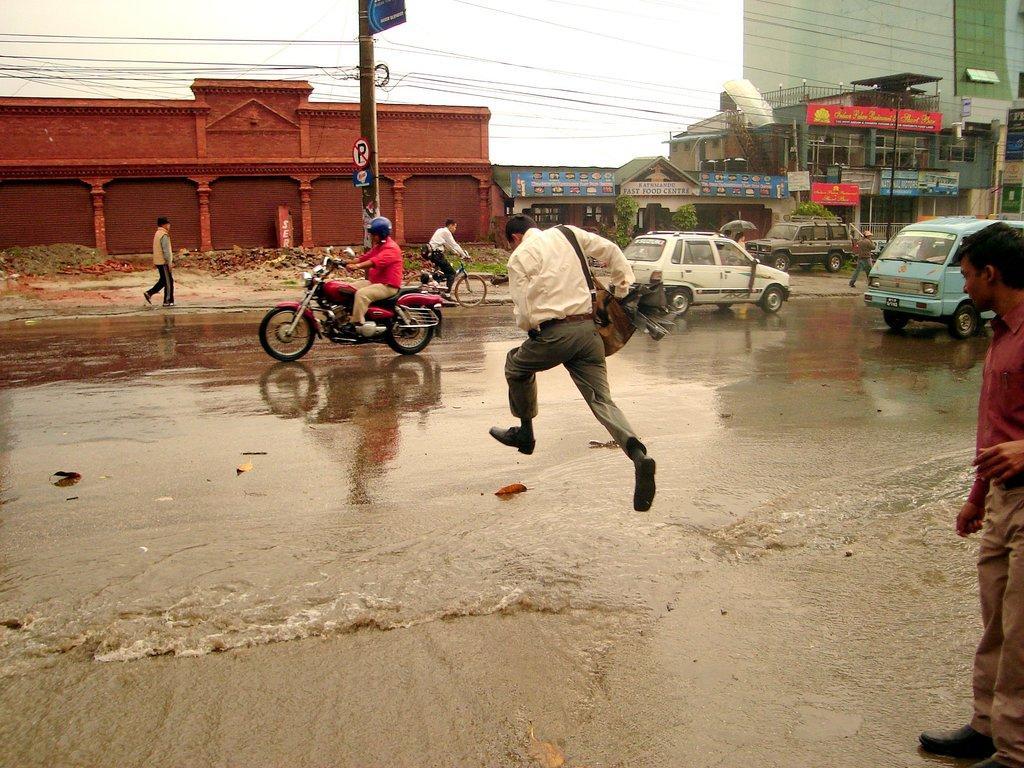Please provide a concise description of this image. In this image I can see a person is jumping into the water. He is wearing a white shirt,pant and shoes. On the road there is a person riding the motorbike and he is wearing the helmet. To the side there are many vehicles and a person is standing on the road. In the back there are shops and some boards are attached to them. I can see a current pole and a brown wall. There is a sky in the background. 